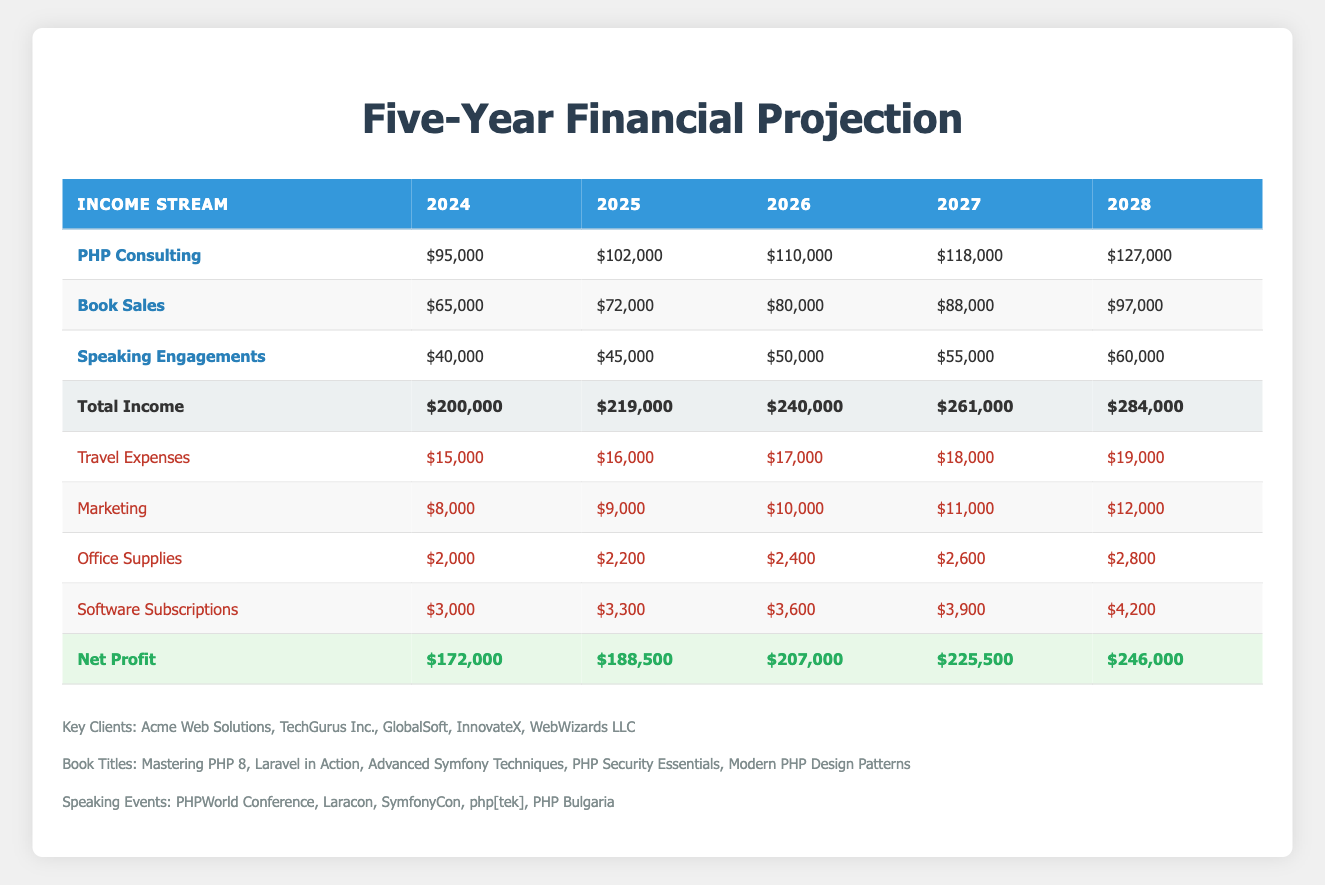What is the projected income from PHP Consulting in 2026? The table shows the income projections for PHP Consulting for each year. Specifically, for 2026, the projection is $110,000.
Answer: $110,000 What is the total income projected for the year 2025? Looking at the total income row for the year 2025, the value is $219,000.
Answer: $219,000 What is the average income from Book Sales over the five years? To find the average, we add the projected income for Book Sales: ($65,000 + $72,000 + $80,000 + $88,000 + $97,000) = $402,000. We then divide by the number of years (5), resulting in an average of $402,000 / 5 = $80,400.
Answer: $80,400 Is the Net Profit in 2028 greater than $250,000? Checking the Net Profit row for 2028, the value is $246,000, which is not greater than $250,000.
Answer: No What is the sum of Travel and Marketing Expenses in 2027? The Travel Expenses for 2027 is $18,000 and Marketing Expenses is $11,000. Summing them gives $18,000 + $11,000 = $29,000.
Answer: $29,000 What is the income difference between the PHP Consulting and Speaking Engagements in 2024? For 2024, the income from PHP Consulting is $95,000 and from Speaking Engagements is $40,000. The difference is $95,000 - $40,000 = $55,000.
Answer: $55,000 Are the projected earnings from Speaking Engagements increasing every year? By observing the projected values for Speaking Engagements, they are: $40,000, $45,000, $50,000, $55,000, and $60,000. Since these numbers are increasing from year to year, the answer is yes.
Answer: Yes What is the total projected income from all streams in 2026? The total projected income for 2026 is shown at the bottom of the table as $240,000. This value includes all income streams combined.
Answer: $240,000 What is the increase in office supplies expenses from 2024 to 2028? The office supplies expenses are $2,000 in 2024 and $2,800 in 2028. The increase is calculated as $2,800 - $2,000 = $800.
Answer: $800 